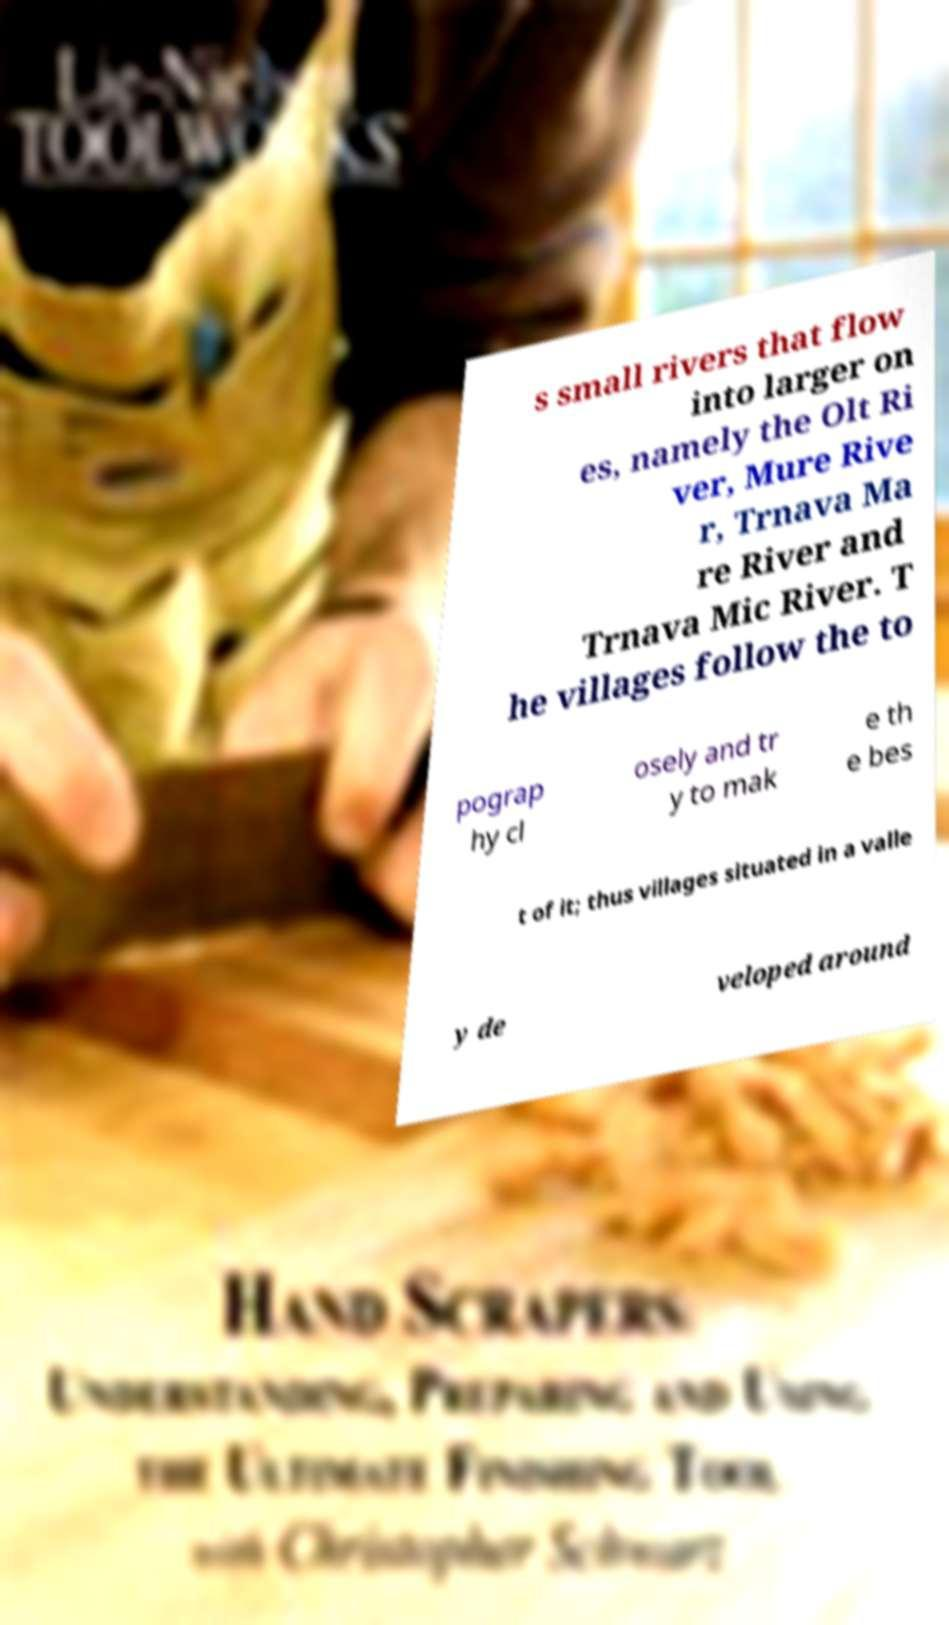Please identify and transcribe the text found in this image. s small rivers that flow into larger on es, namely the Olt Ri ver, Mure Rive r, Trnava Ma re River and Trnava Mic River. T he villages follow the to pograp hy cl osely and tr y to mak e th e bes t of it; thus villages situated in a valle y de veloped around 